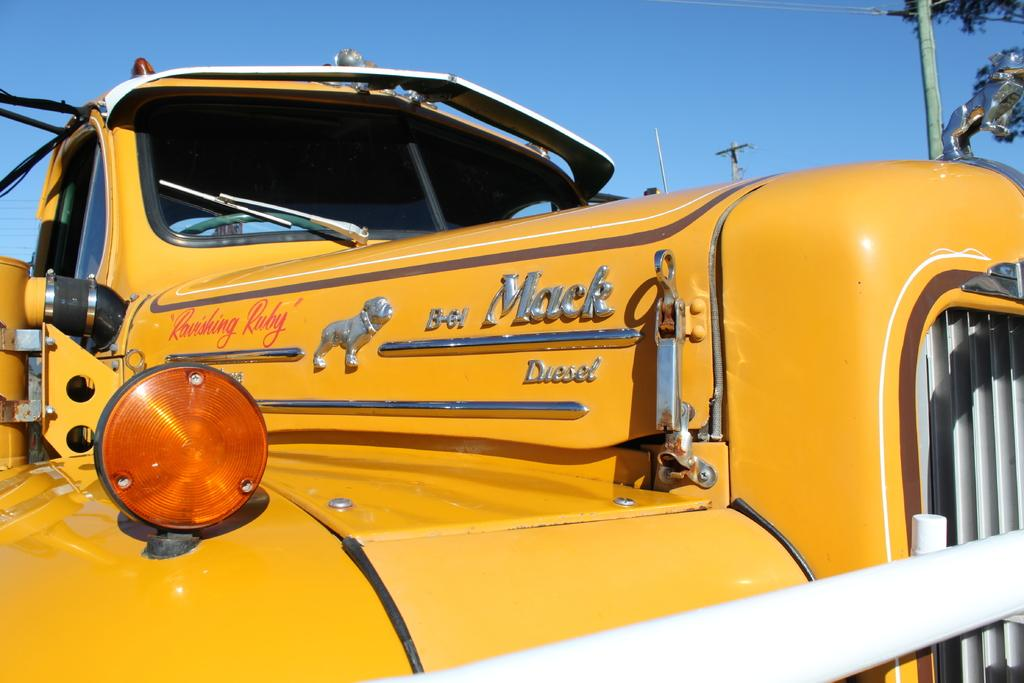What is the main subject in the image? There is a vehicle in the image. What can be seen in the background of the image? There are poles and a tree in the background of the image. What type of beast can be seen running alongside the vehicle in the image? There is no beast present in the image; it only features a vehicle and background elements. 